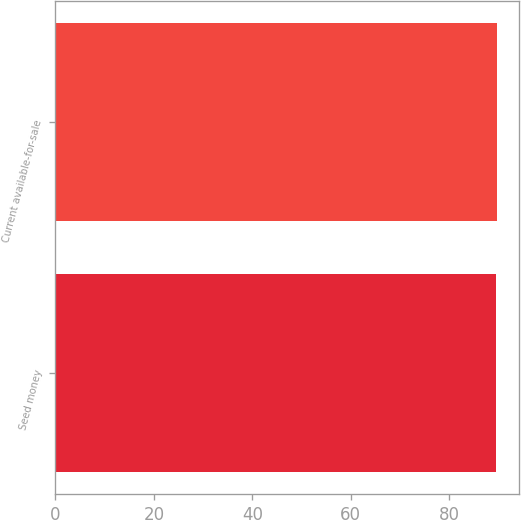<chart> <loc_0><loc_0><loc_500><loc_500><bar_chart><fcel>Seed money<fcel>Current available-for-sale<nl><fcel>89.6<fcel>89.7<nl></chart> 